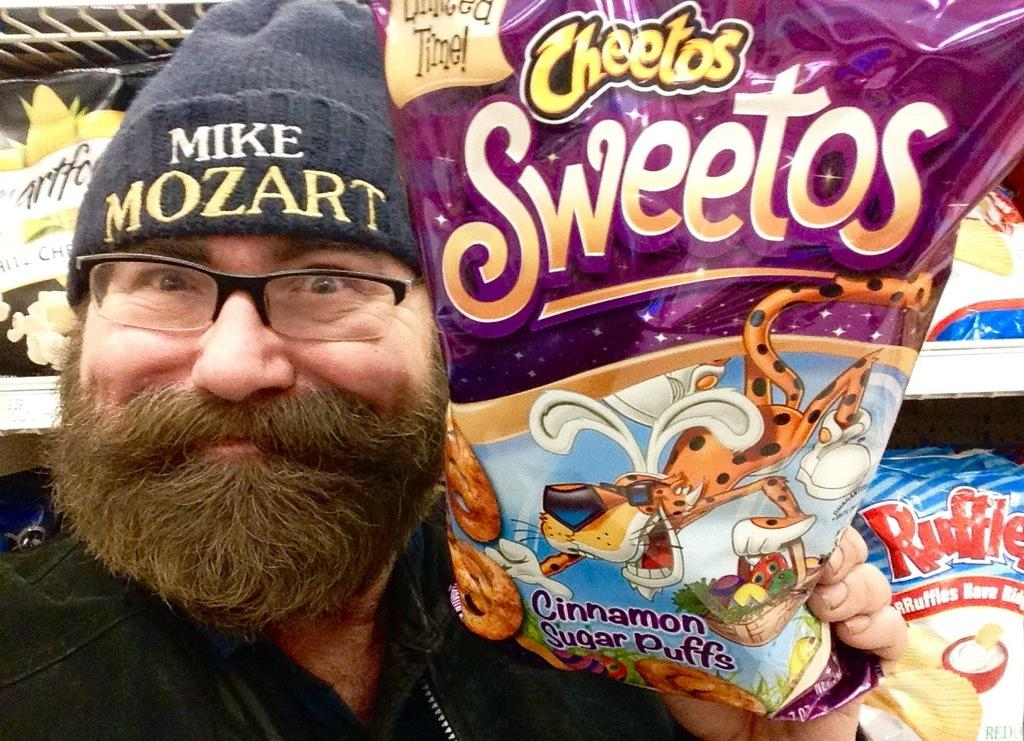Who or what is the main subject in the image? There is a person in the image. What is the person holding in the image? The person is holding a packet. Can you describe the packet in the image? The packet has text on it. What can be seen in the background of the image? There are objects placed in racks in the background of the image. What type of house does the achiever live in, as seen in the image? There is no house or achiever mentioned in the image; it only features a person holding a packet with text on it and objects placed in racks in the background. 